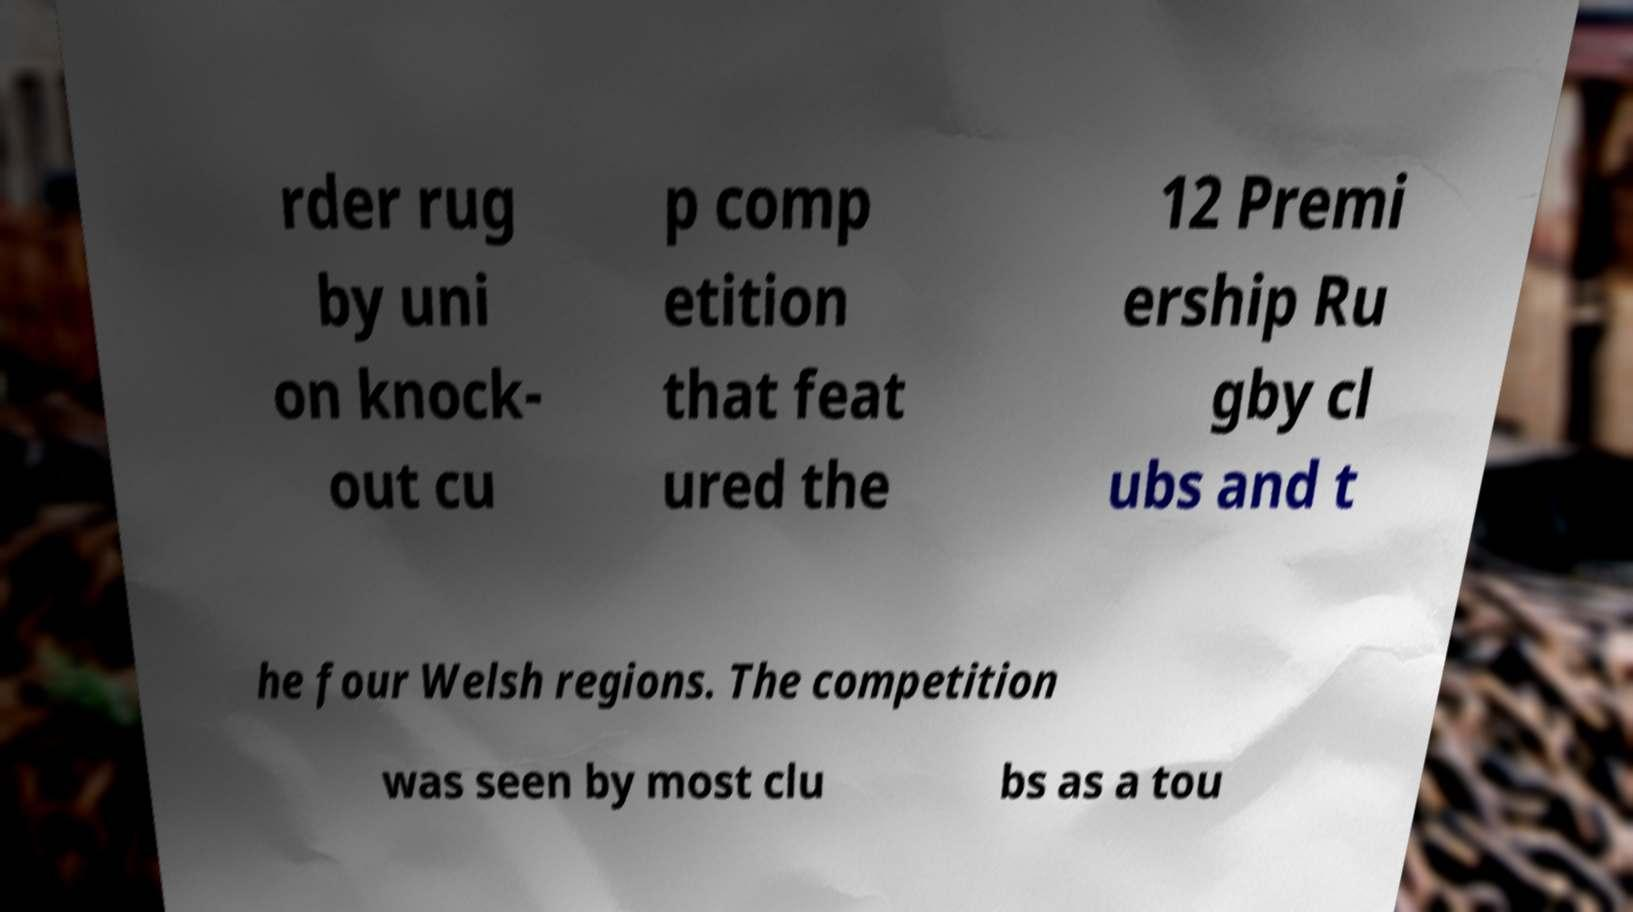Could you extract and type out the text from this image? rder rug by uni on knock- out cu p comp etition that feat ured the 12 Premi ership Ru gby cl ubs and t he four Welsh regions. The competition was seen by most clu bs as a tou 